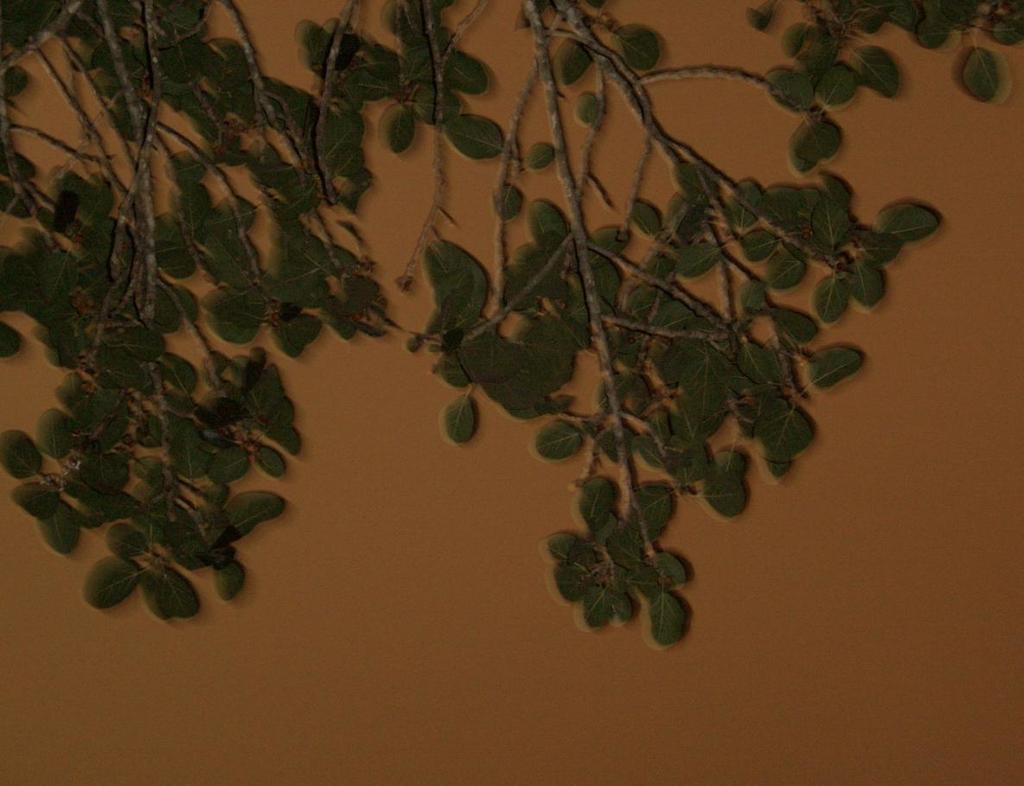How would you summarize this image in a sentence or two? In this picture we can see branches with leaves and in the background we can see the wall. 